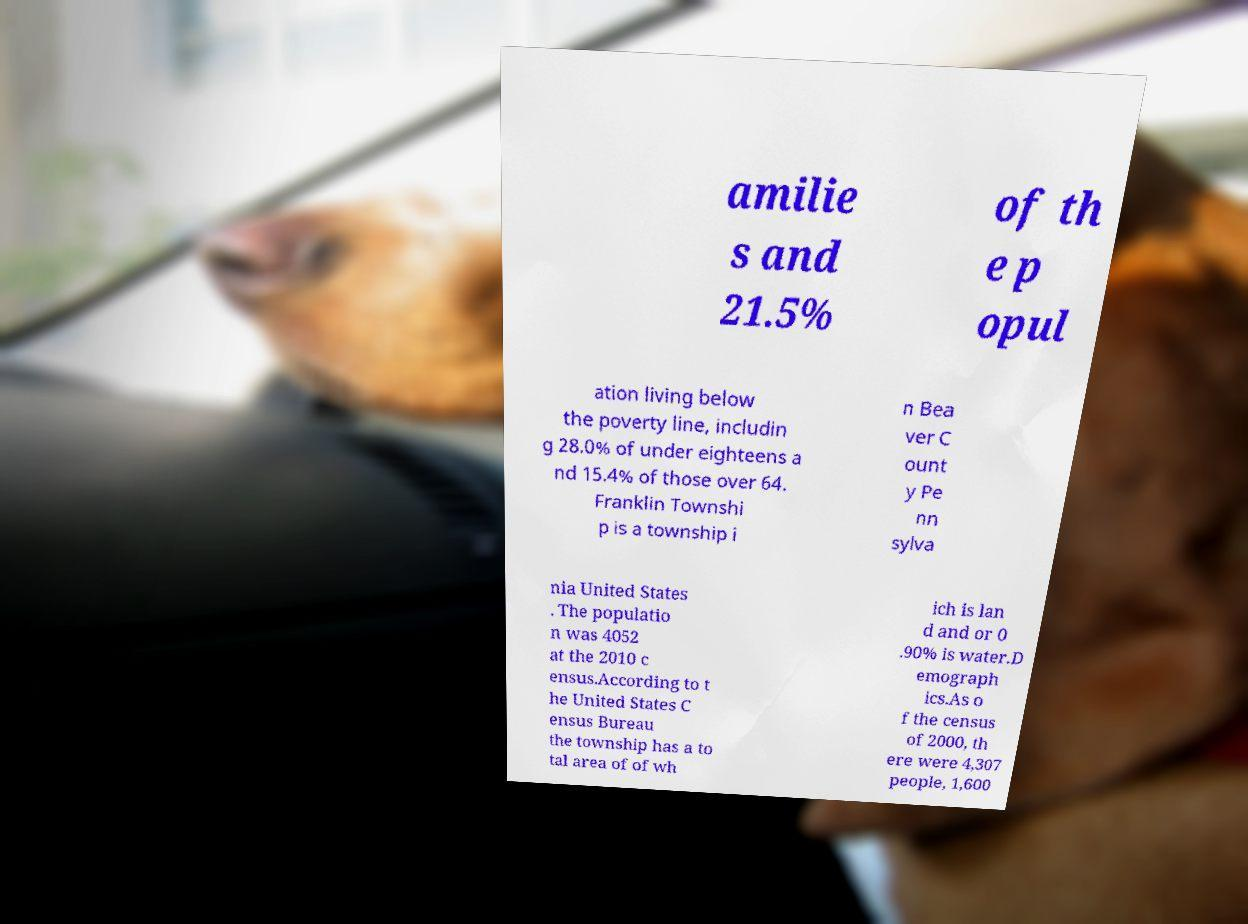Can you accurately transcribe the text from the provided image for me? amilie s and 21.5% of th e p opul ation living below the poverty line, includin g 28.0% of under eighteens a nd 15.4% of those over 64. Franklin Townshi p is a township i n Bea ver C ount y Pe nn sylva nia United States . The populatio n was 4052 at the 2010 c ensus.According to t he United States C ensus Bureau the township has a to tal area of of wh ich is lan d and or 0 .90% is water.D emograph ics.As o f the census of 2000, th ere were 4,307 people, 1,600 